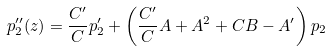Convert formula to latex. <formula><loc_0><loc_0><loc_500><loc_500>p _ { 2 } ^ { \prime \prime } ( z ) = \frac { C ^ { \prime } } C p ^ { \prime } _ { 2 } + \left ( \frac { C ^ { \prime } } C A + A ^ { 2 } + C B - A ^ { \prime } \right ) p _ { 2 }</formula> 